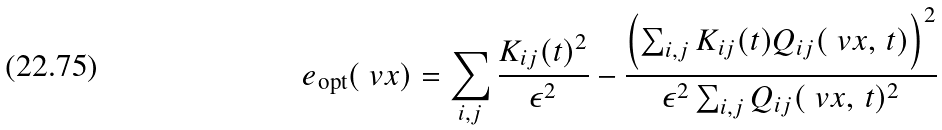Convert formula to latex. <formula><loc_0><loc_0><loc_500><loc_500>e _ { \text {opt} } ( \ v x ) = \sum _ { i , j } \frac { K _ { i j } ( t ) ^ { 2 } } { \epsilon ^ { 2 } } - \frac { \left ( \sum _ { i , j } K _ { i j } ( t ) Q _ { i j } ( \ v x , \, t ) \right ) ^ { 2 } } { \epsilon ^ { 2 } \sum _ { i , j } Q _ { i j } ( \ v x , \, t ) ^ { 2 } }</formula> 